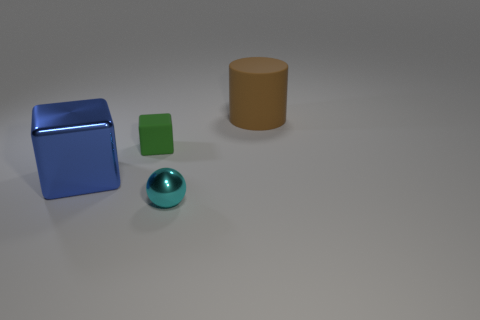There is a large thing on the left side of the cyan metal object; how many cyan things are to the left of it?
Keep it short and to the point. 0. Is the size of the cylinder the same as the object that is on the left side of the small green matte cube?
Your answer should be compact. Yes. Is the size of the matte cylinder the same as the green rubber cube?
Provide a succinct answer. No. Is there a matte object of the same size as the brown rubber cylinder?
Your answer should be compact. No. There is a big thing that is in front of the brown cylinder; what material is it?
Provide a short and direct response. Metal. What is the color of the small object that is the same material as the cylinder?
Provide a short and direct response. Green. How many metallic objects are either small cubes or big green cubes?
Keep it short and to the point. 0. The blue thing that is the same size as the brown matte thing is what shape?
Offer a very short reply. Cube. What number of objects are either large brown things that are right of the small cyan thing or objects that are to the right of the tiny cyan metallic object?
Your answer should be very brief. 1. There is a brown cylinder that is the same size as the blue shiny object; what material is it?
Your answer should be very brief. Rubber. 